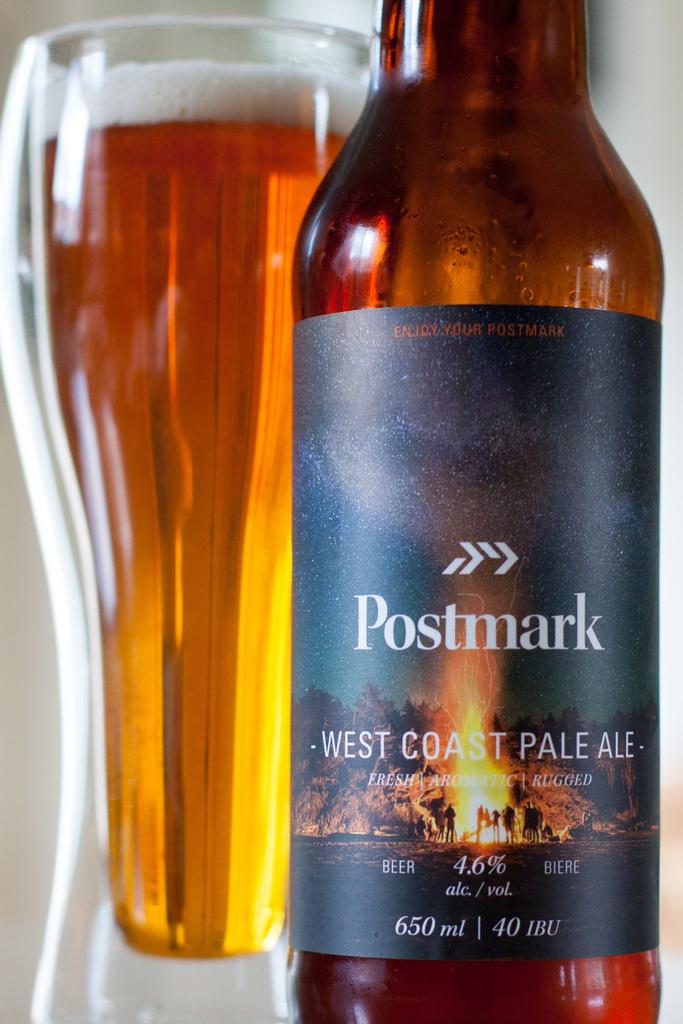What kind of beer is this?
Provide a short and direct response. West coast pale ale. How many ml's are in a bottle?
Provide a short and direct response. 650. 